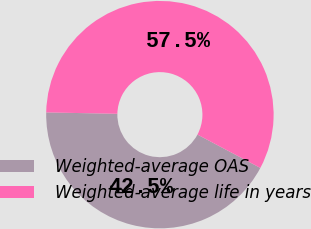Convert chart. <chart><loc_0><loc_0><loc_500><loc_500><pie_chart><fcel>Weighted-average OAS<fcel>Weighted-average life in years<nl><fcel>42.55%<fcel>57.45%<nl></chart> 